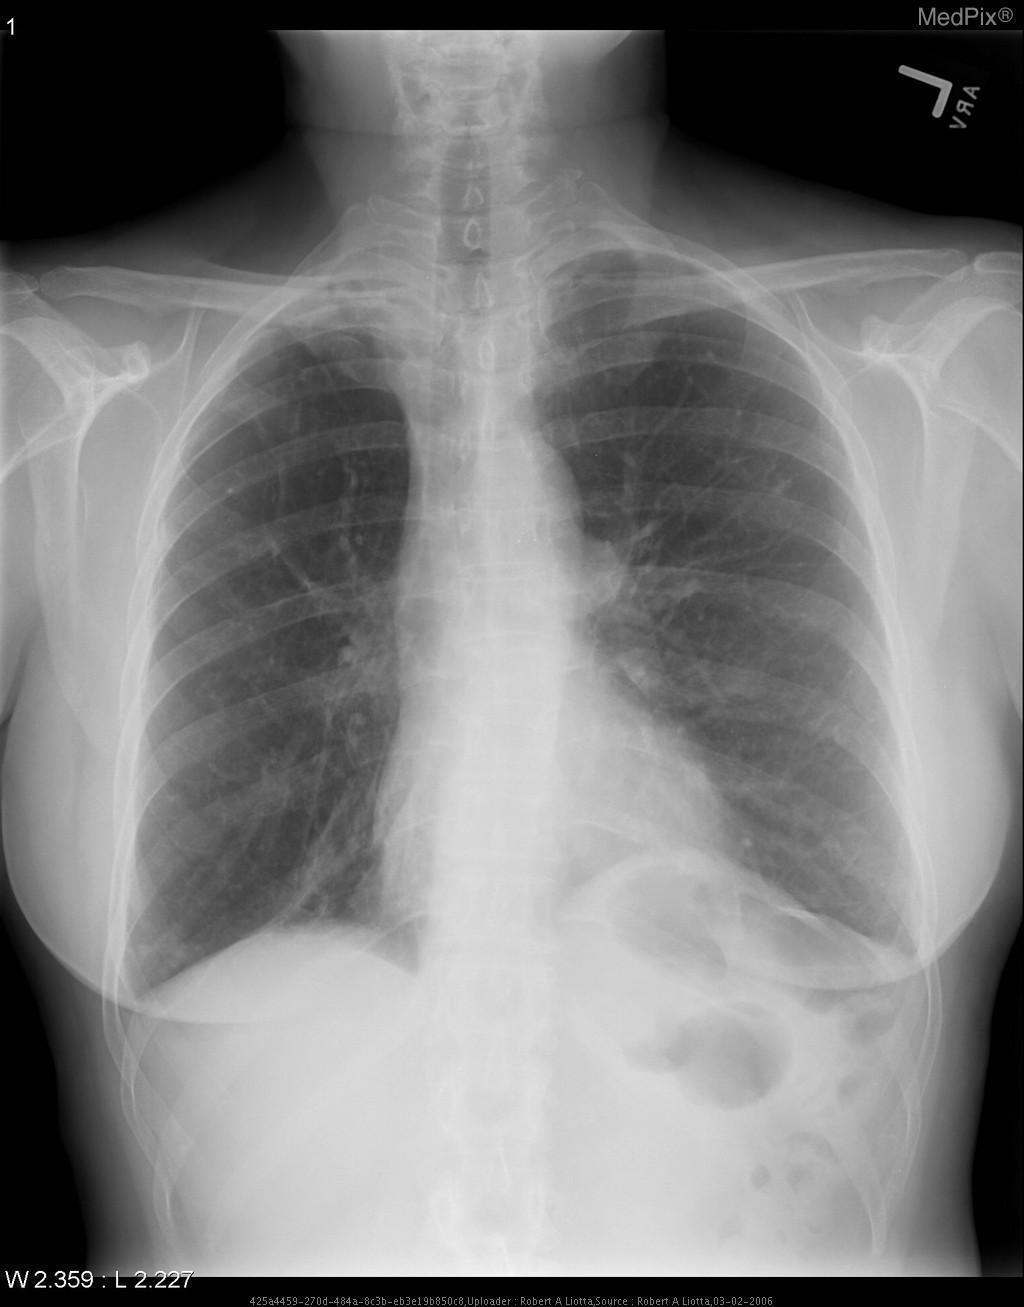Is this an anterior posterior image?
Keep it brief. No. What type of imaging does this not represent?
Short answer required. Ultrasound. What is not pictured in this image?
Short answer required. The extremities. Is the trachea midline?
Concise answer only. Yes. Is there evidence of an aortic aneurysm?
Short answer required. No. Is there blunting of the costovertebral angles?
Concise answer only. No. 